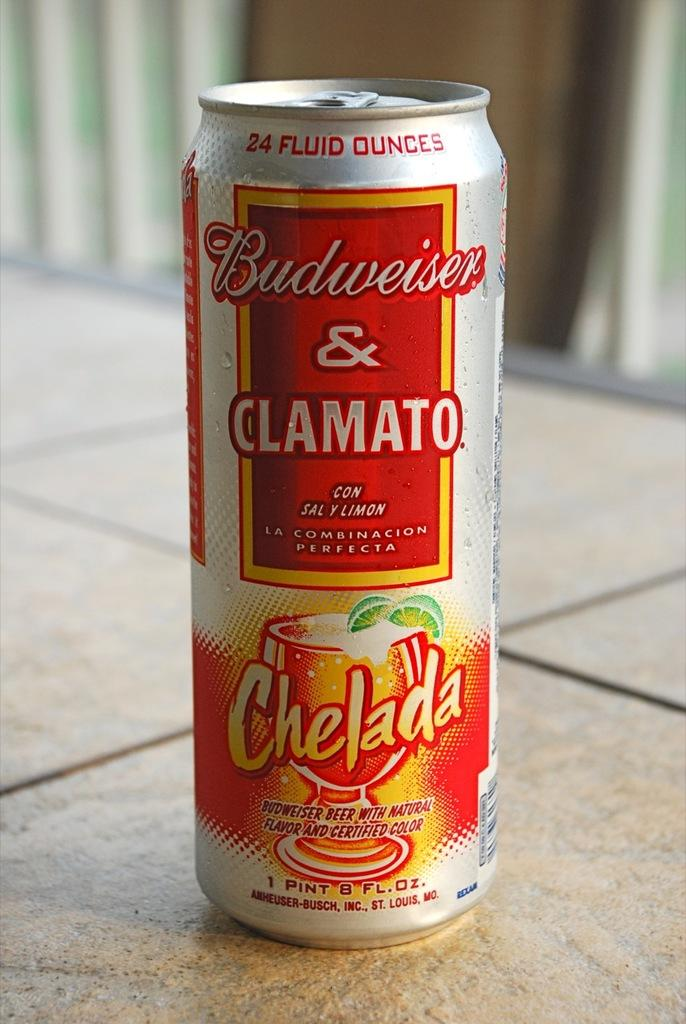<image>
Create a compact narrative representing the image presented. a Budweiser can with the word Chelada on it 